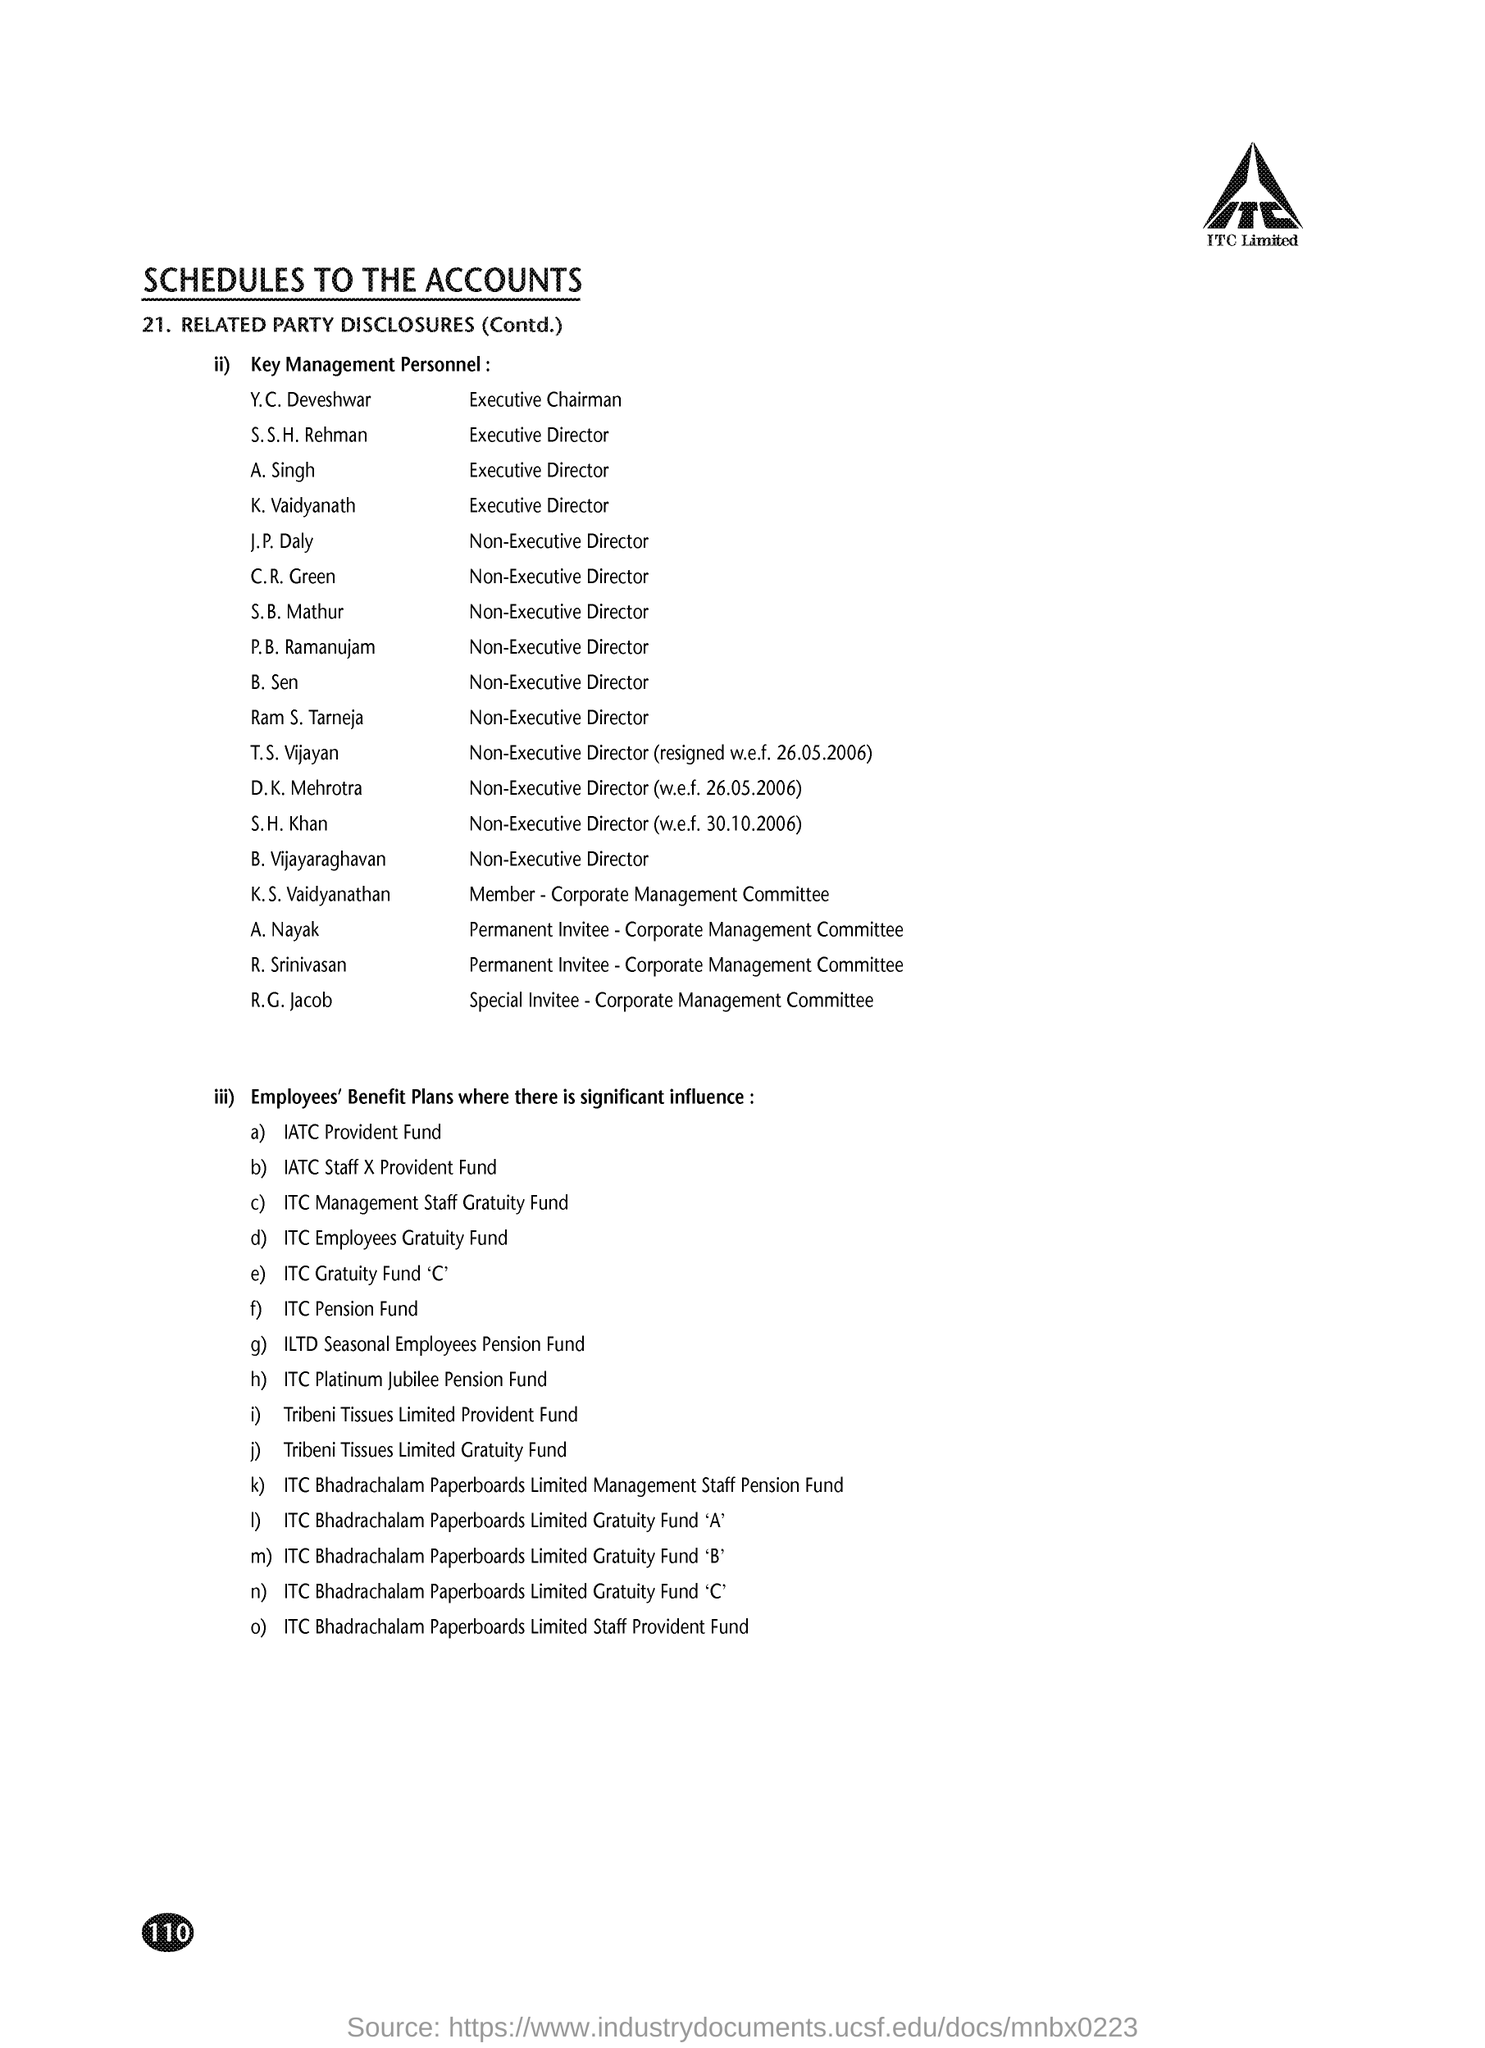Point out several critical features in this image. S. S. H. Rehman holds the designation of Executive Director. ITC Limited is mentioned in the header of the document. 